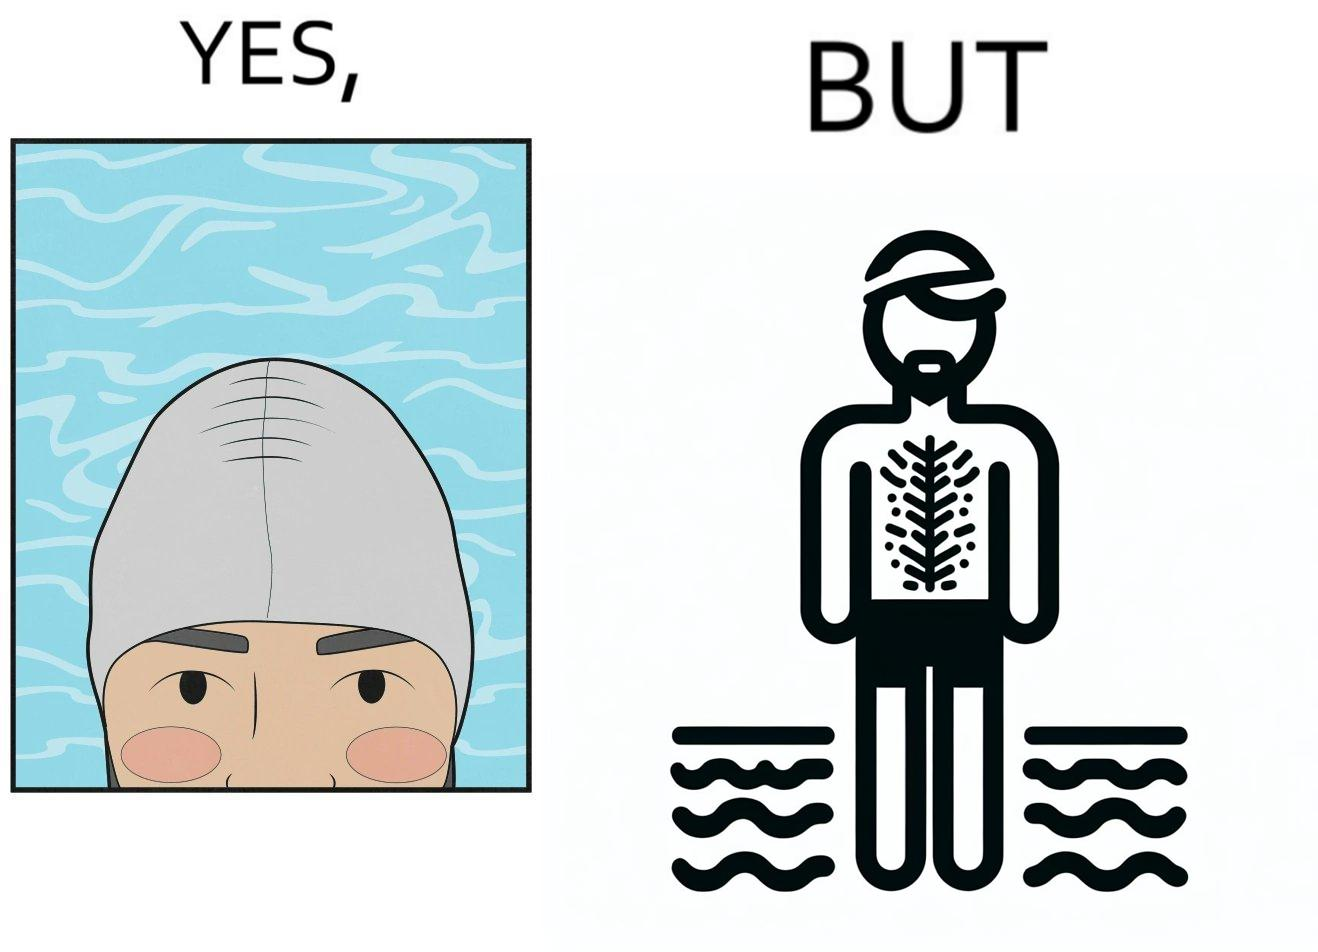What does this image depict? The man is wearing a swimming cap to protect his head's hair but on the other side he is not concerned over the hair all over his body and is nowhere covering them 